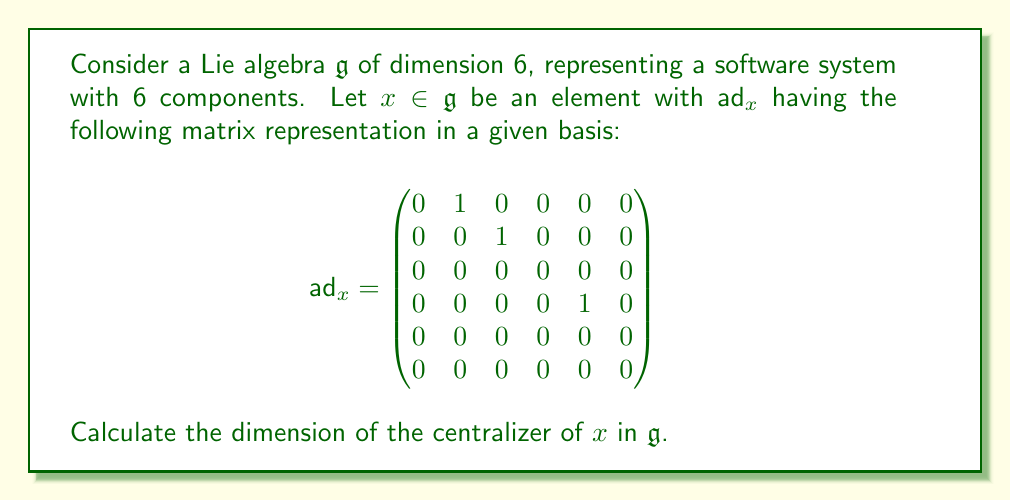Show me your answer to this math problem. To solve this problem, we need to follow these steps:

1) The centralizer of $x$, denoted as $C_{\mathfrak{g}}(x)$, is defined as:

   $C_{\mathfrak{g}}(x) = \{y \in \mathfrak{g} : [x,y] = 0\}$

2) In terms of the adjoint representation, $y$ is in the centralizer of $x$ if and only if $\text{ad}_x(y) = 0$.

3) Therefore, the dimension of the centralizer is equal to the dimension of the kernel of $\text{ad}_x$.

4) To find the dimension of the kernel, we need to find the nullity of $\text{ad}_x$, which is equal to the dimension of $\mathfrak{g}$ minus the rank of $\text{ad}_x$.

5) The rank of $\text{ad}_x$ is equal to the number of linearly independent columns (or rows) in its matrix representation.

6) Looking at the matrix, we can see that there are 3 linearly independent columns: the 2nd, 3rd, and 5th columns.

7) Therefore, the rank of $\text{ad}_x$ is 3.

8) The dimension of the centralizer is thus:

   $\dim C_{\mathfrak{g}}(x) = \dim \mathfrak{g} - \text{rank}(\text{ad}_x) = 6 - 3 = 3$

This result indicates that in our software system analogy, there are 3 components that commute with the given element $x$.
Answer: The dimension of the centralizer of $x$ in $\mathfrak{g}$ is 3. 